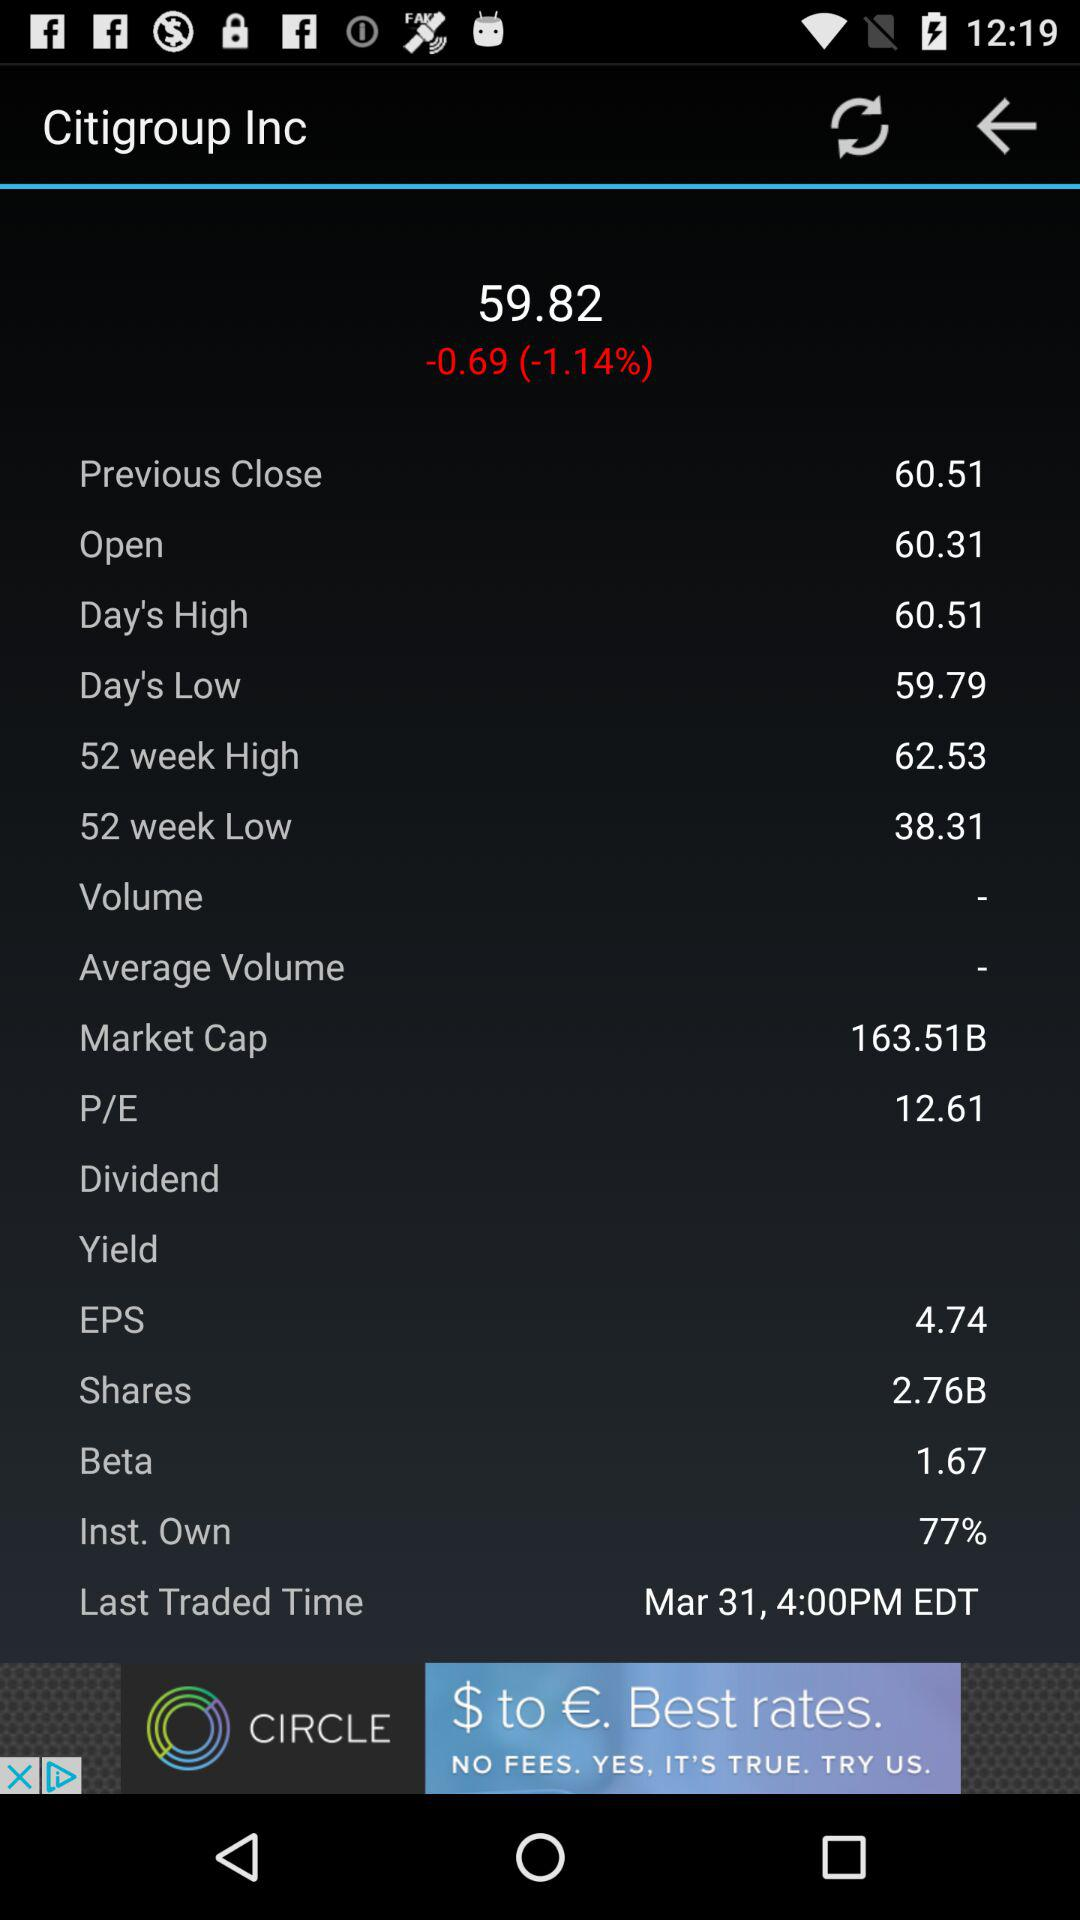What is the market capital of "Citigroup Inc"? The market capital is 163.51B. 